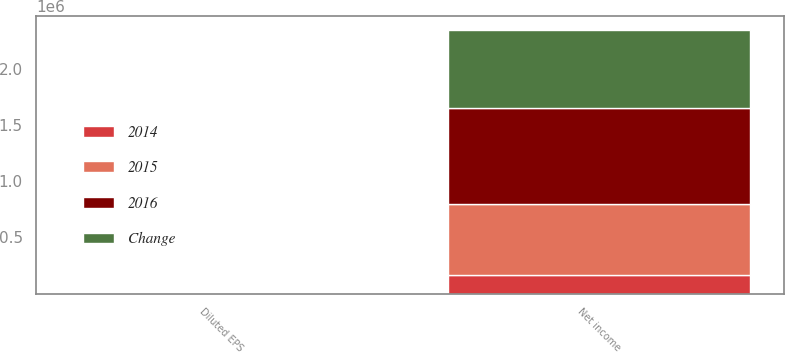Convert chart. <chart><loc_0><loc_0><loc_500><loc_500><stacked_bar_chart><ecel><fcel>Net income<fcel>Diluted EPS<nl><fcel>2016<fcel>861664<fcel>2.76<nl><fcel>Change<fcel>696878<fcel>2.2<nl><fcel>2015<fcel>629320<fcel>1.98<nl><fcel>2014<fcel>164786<fcel>0.56<nl></chart> 